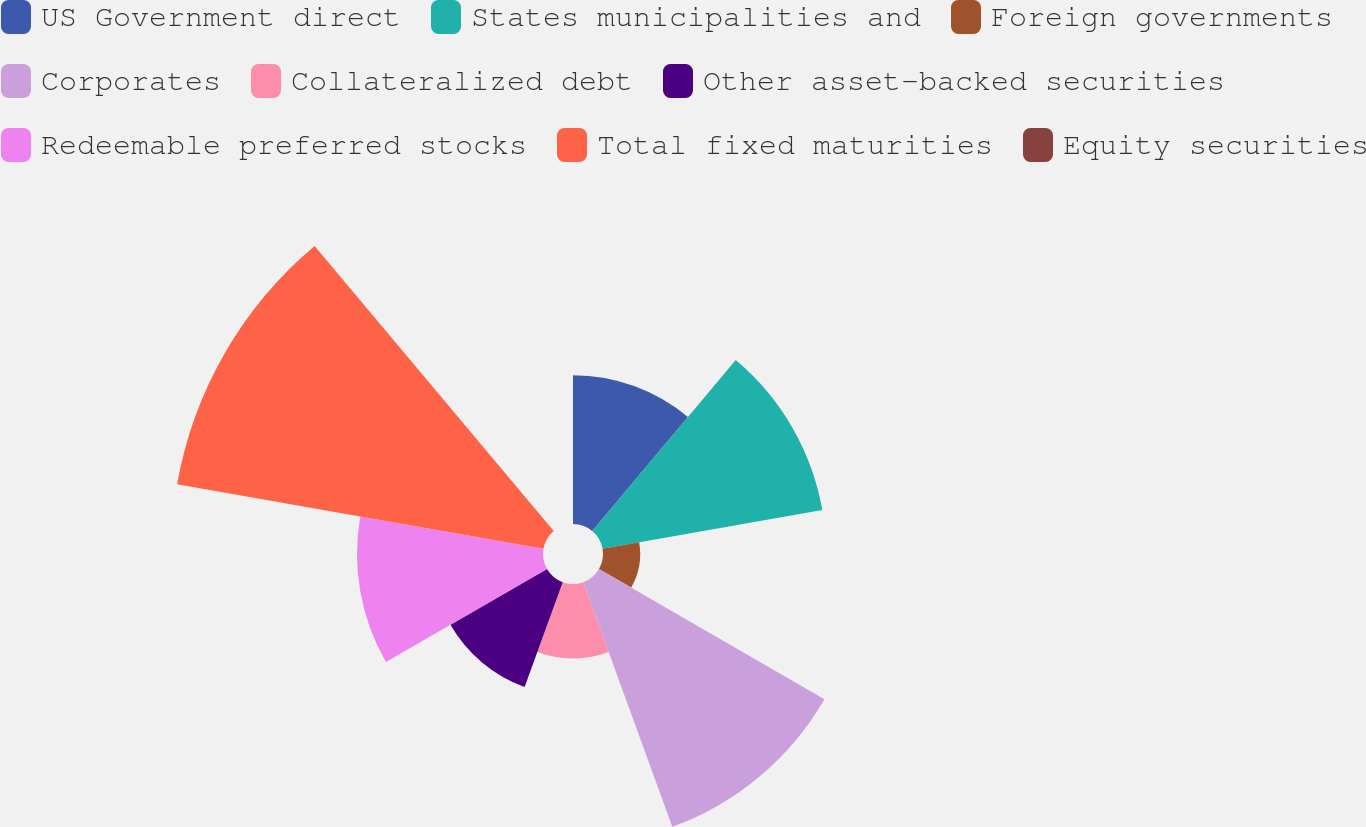Convert chart. <chart><loc_0><loc_0><loc_500><loc_500><pie_chart><fcel>US Government direct<fcel>States municipalities and<fcel>Foreign governments<fcel>Corporates<fcel>Collateralized debt<fcel>Other asset-backed securities<fcel>Redeemable preferred stocks<fcel>Total fixed maturities<fcel>Equity securities<nl><fcel>10.53%<fcel>15.79%<fcel>2.63%<fcel>18.42%<fcel>5.26%<fcel>7.89%<fcel>13.16%<fcel>26.32%<fcel>0.0%<nl></chart> 